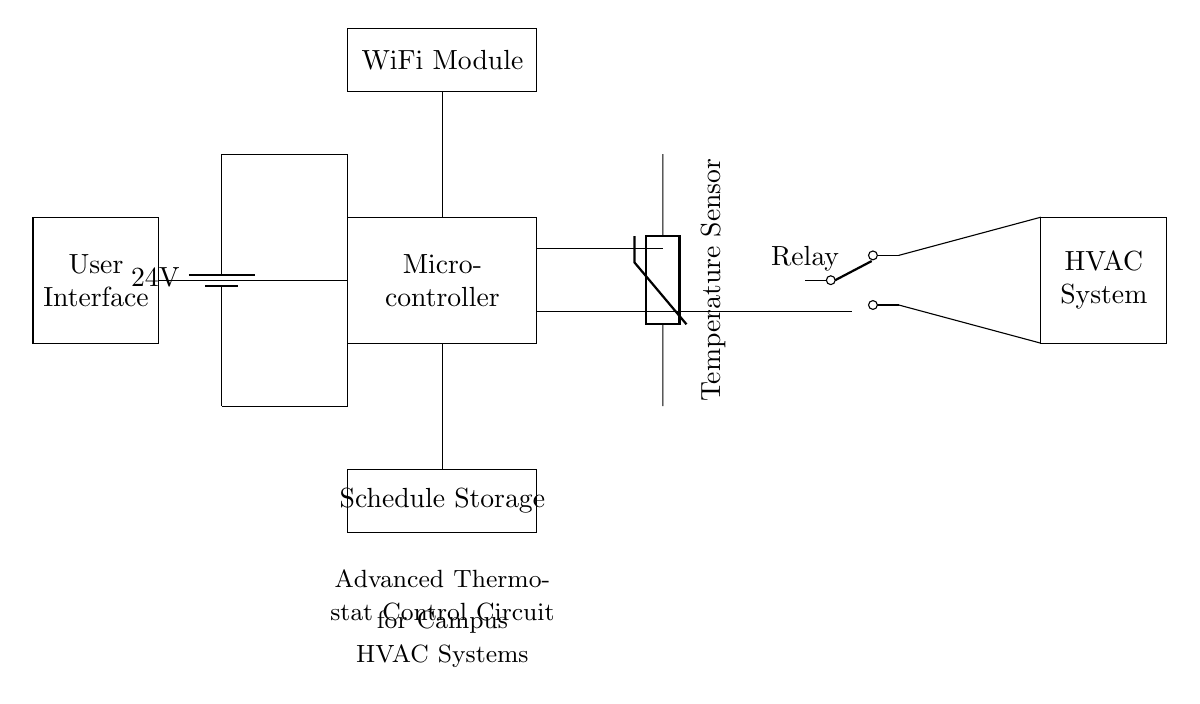What is the primary function of the microcontroller in this circuit? The microcontroller's primary function is to process inputs from the temperature sensor and manage the HVAC system accordingly through programmable scheduling.
Answer: processing inputs What is the voltage supply for the circuit? The circuit is powered by a battery supplying 24 volts. This is indicated by the battery symbol and the label next to it.
Answer: 24 volts What type of component is used to sense temperature? A thermistor is used as the temperature sensor, which is shown in the diagram with its specific symbol.
Answer: thermistor How many outputs does the relay have? The relay shown in the diagram has two outputs, indicated by the two lines connecting to it.
Answer: two outputs What additional feature does the WiFi module provide in this circuit? The WiFi module enables remote communication or control of the thermostat, facilitating easy scheduling adjustments and monitoring from a distance.
Answer: remote control What is stored in the schedule storage section of the circuit? The schedule storage section is designed to hold the programmable settings for the thermostat's operation, which helps in managing the HVAC system's efficiency.
Answer: programmable settings Which component connects the user interface to the microcontroller? There is a direct connection line between the user interface and the microcontroller, allowing users to input their scheduling preferences and temperature settings.
Answer: direct connection 